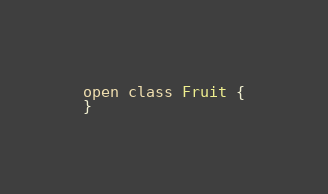Convert code to text. <code><loc_0><loc_0><loc_500><loc_500><_Kotlin_>open class Fruit {
}</code> 